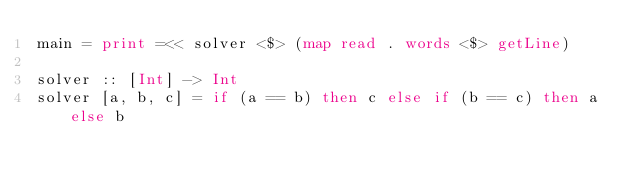Convert code to text. <code><loc_0><loc_0><loc_500><loc_500><_Haskell_>main = print =<< solver <$> (map read . words <$> getLine)
 
solver :: [Int] -> Int
solver [a, b, c] = if (a == b) then c else if (b == c) then a else b</code> 